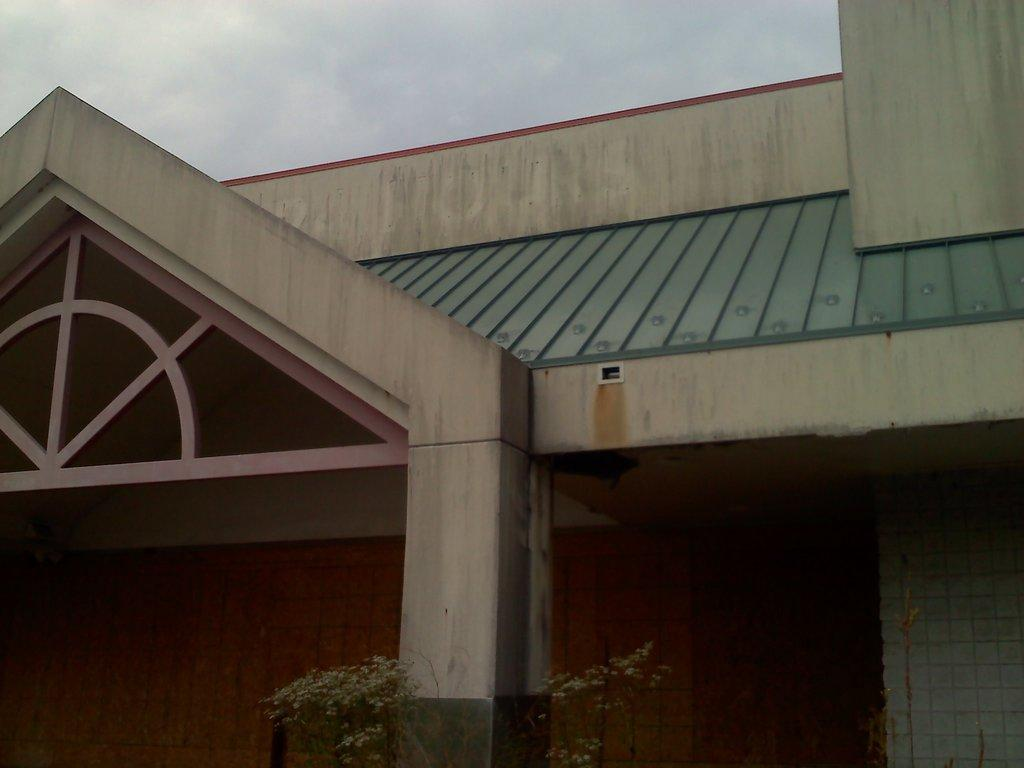What can be seen in the background of the image? The sky is visible in the background of the image. What type of structure is present in the image? There is a house in the image. What architectural feature can be seen in the image? There is a wall and a pillar in the image. What type of vegetation is present in the image? A plant is present at the bottom portion of the image. How many brothers are playing with the spade in the image? There is no spade or brothers present in the image. What is the value of the cent in the image? There is no cent present in the image. 